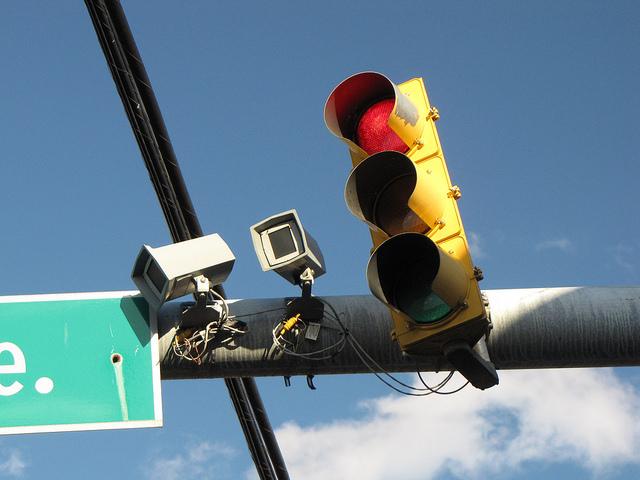What color is on the traffic light?
Concise answer only. Red. Are there any clouds visible in the sky?
Keep it brief. Yes. What is the letter partially visible on the green sign?
Be succinct. E. How many red lights?
Concise answer only. 1. What is the purpose of these cameras?
Give a very brief answer. Traffic violations. 